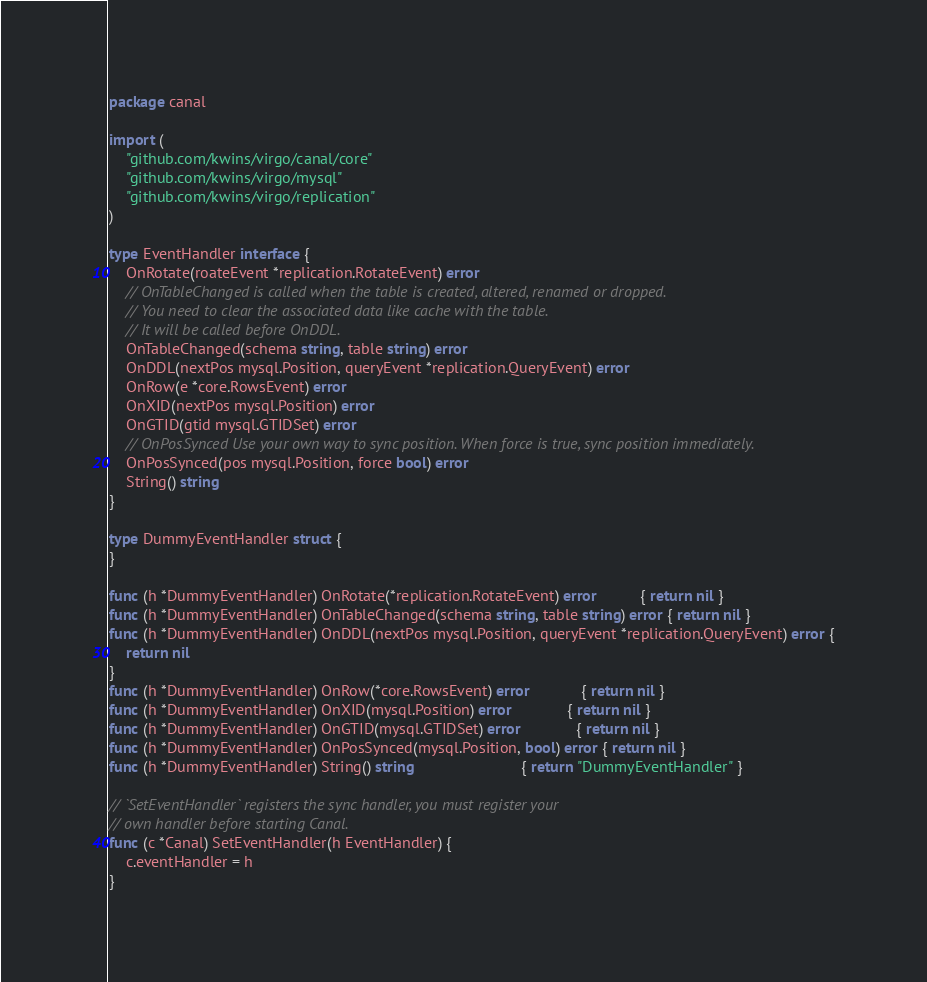<code> <loc_0><loc_0><loc_500><loc_500><_Go_>package canal

import (
	"github.com/kwins/virgo/canal/core"
	"github.com/kwins/virgo/mysql"
	"github.com/kwins/virgo/replication"
)

type EventHandler interface {
	OnRotate(roateEvent *replication.RotateEvent) error
	// OnTableChanged is called when the table is created, altered, renamed or dropped.
	// You need to clear the associated data like cache with the table.
	// It will be called before OnDDL.
	OnTableChanged(schema string, table string) error
	OnDDL(nextPos mysql.Position, queryEvent *replication.QueryEvent) error
	OnRow(e *core.RowsEvent) error
	OnXID(nextPos mysql.Position) error
	OnGTID(gtid mysql.GTIDSet) error
	// OnPosSynced Use your own way to sync position. When force is true, sync position immediately.
	OnPosSynced(pos mysql.Position, force bool) error
	String() string
}

type DummyEventHandler struct {
}

func (h *DummyEventHandler) OnRotate(*replication.RotateEvent) error          { return nil }
func (h *DummyEventHandler) OnTableChanged(schema string, table string) error { return nil }
func (h *DummyEventHandler) OnDDL(nextPos mysql.Position, queryEvent *replication.QueryEvent) error {
	return nil
}
func (h *DummyEventHandler) OnRow(*core.RowsEvent) error            { return nil }
func (h *DummyEventHandler) OnXID(mysql.Position) error             { return nil }
func (h *DummyEventHandler) OnGTID(mysql.GTIDSet) error             { return nil }
func (h *DummyEventHandler) OnPosSynced(mysql.Position, bool) error { return nil }
func (h *DummyEventHandler) String() string                         { return "DummyEventHandler" }

// `SetEventHandler` registers the sync handler, you must register your
// own handler before starting Canal.
func (c *Canal) SetEventHandler(h EventHandler) {
	c.eventHandler = h
}
</code> 